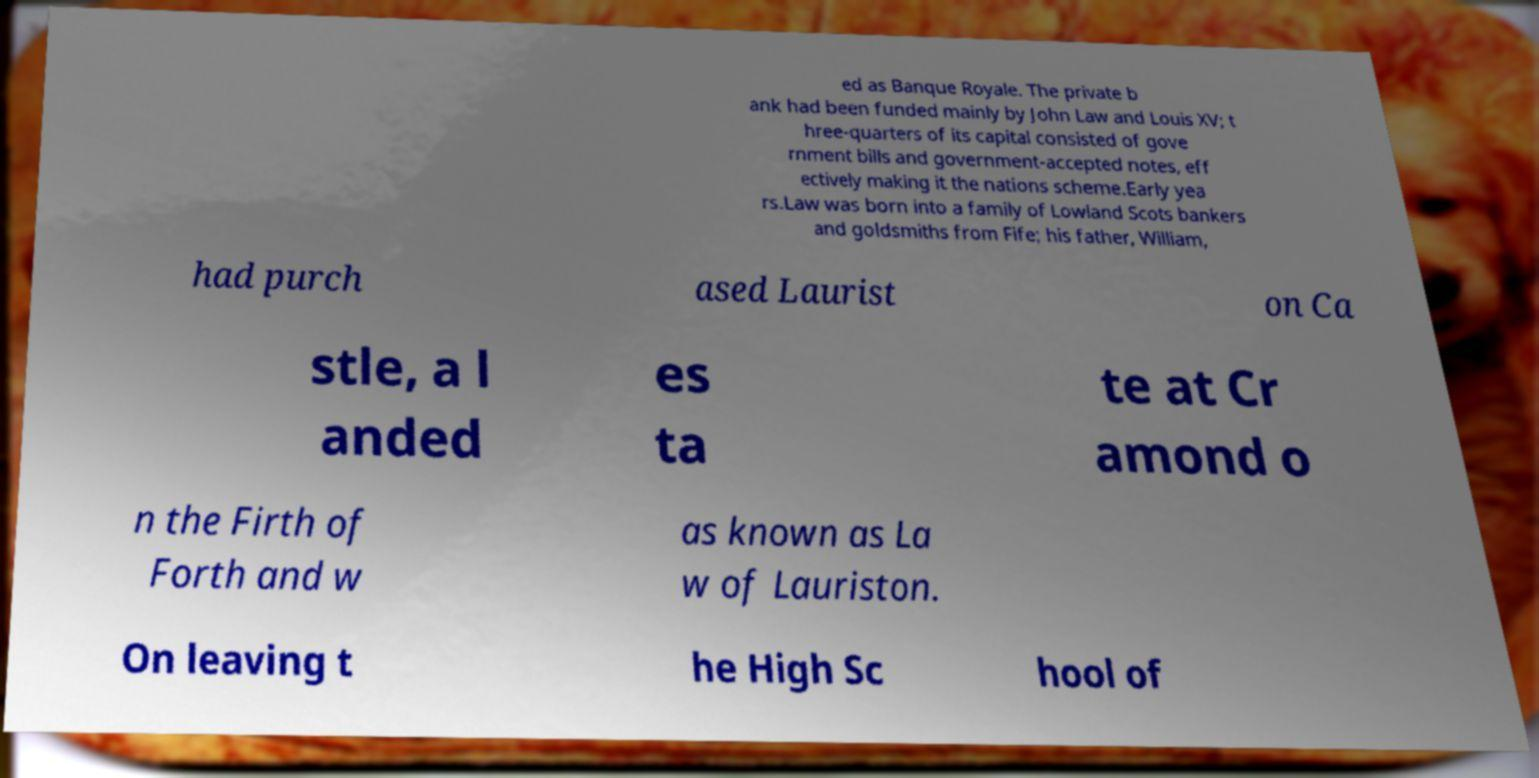Could you extract and type out the text from this image? ed as Banque Royale. The private b ank had been funded mainly by John Law and Louis XV; t hree-quarters of its capital consisted of gove rnment bills and government-accepted notes, eff ectively making it the nations scheme.Early yea rs.Law was born into a family of Lowland Scots bankers and goldsmiths from Fife; his father, William, had purch ased Laurist on Ca stle, a l anded es ta te at Cr amond o n the Firth of Forth and w as known as La w of Lauriston. On leaving t he High Sc hool of 